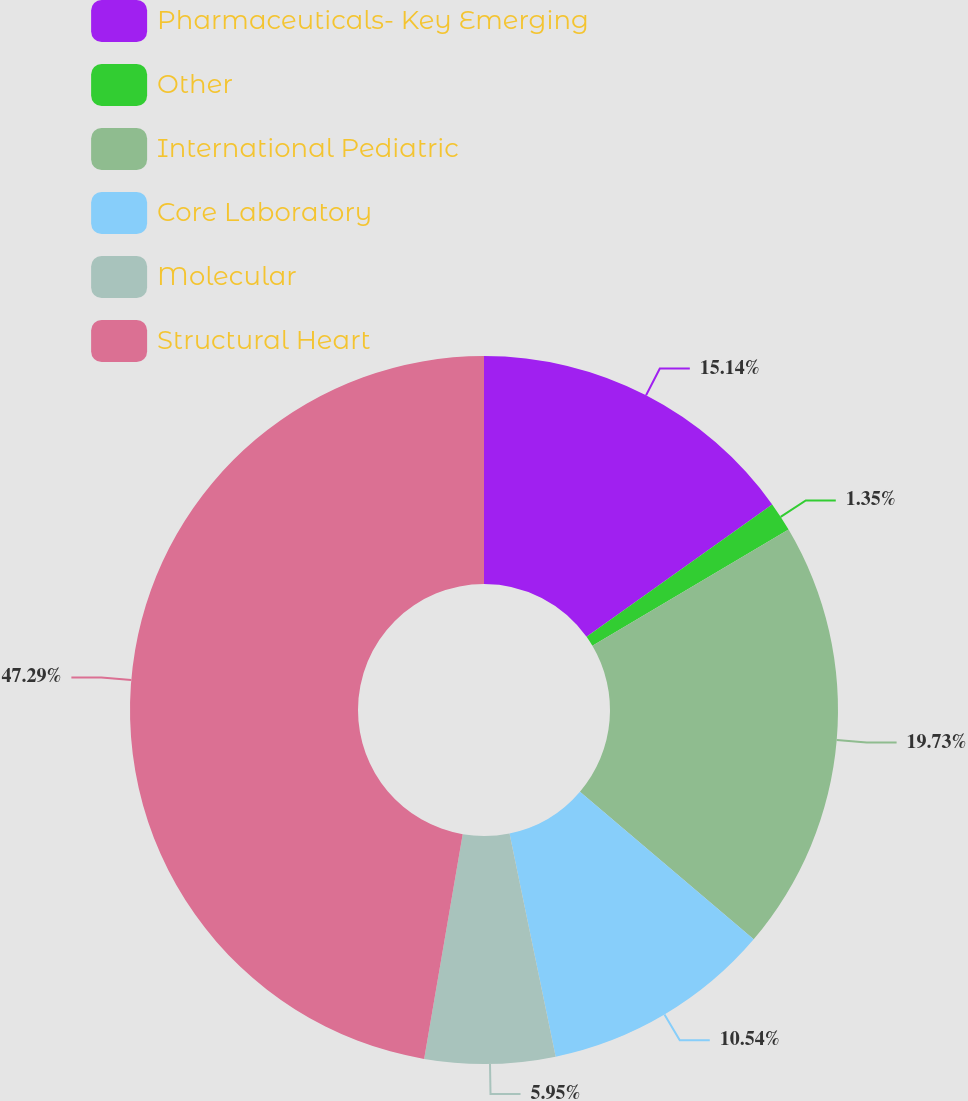<chart> <loc_0><loc_0><loc_500><loc_500><pie_chart><fcel>Pharmaceuticals- Key Emerging<fcel>Other<fcel>International Pediatric<fcel>Core Laboratory<fcel>Molecular<fcel>Structural Heart<nl><fcel>15.14%<fcel>1.35%<fcel>19.73%<fcel>10.54%<fcel>5.95%<fcel>47.3%<nl></chart> 